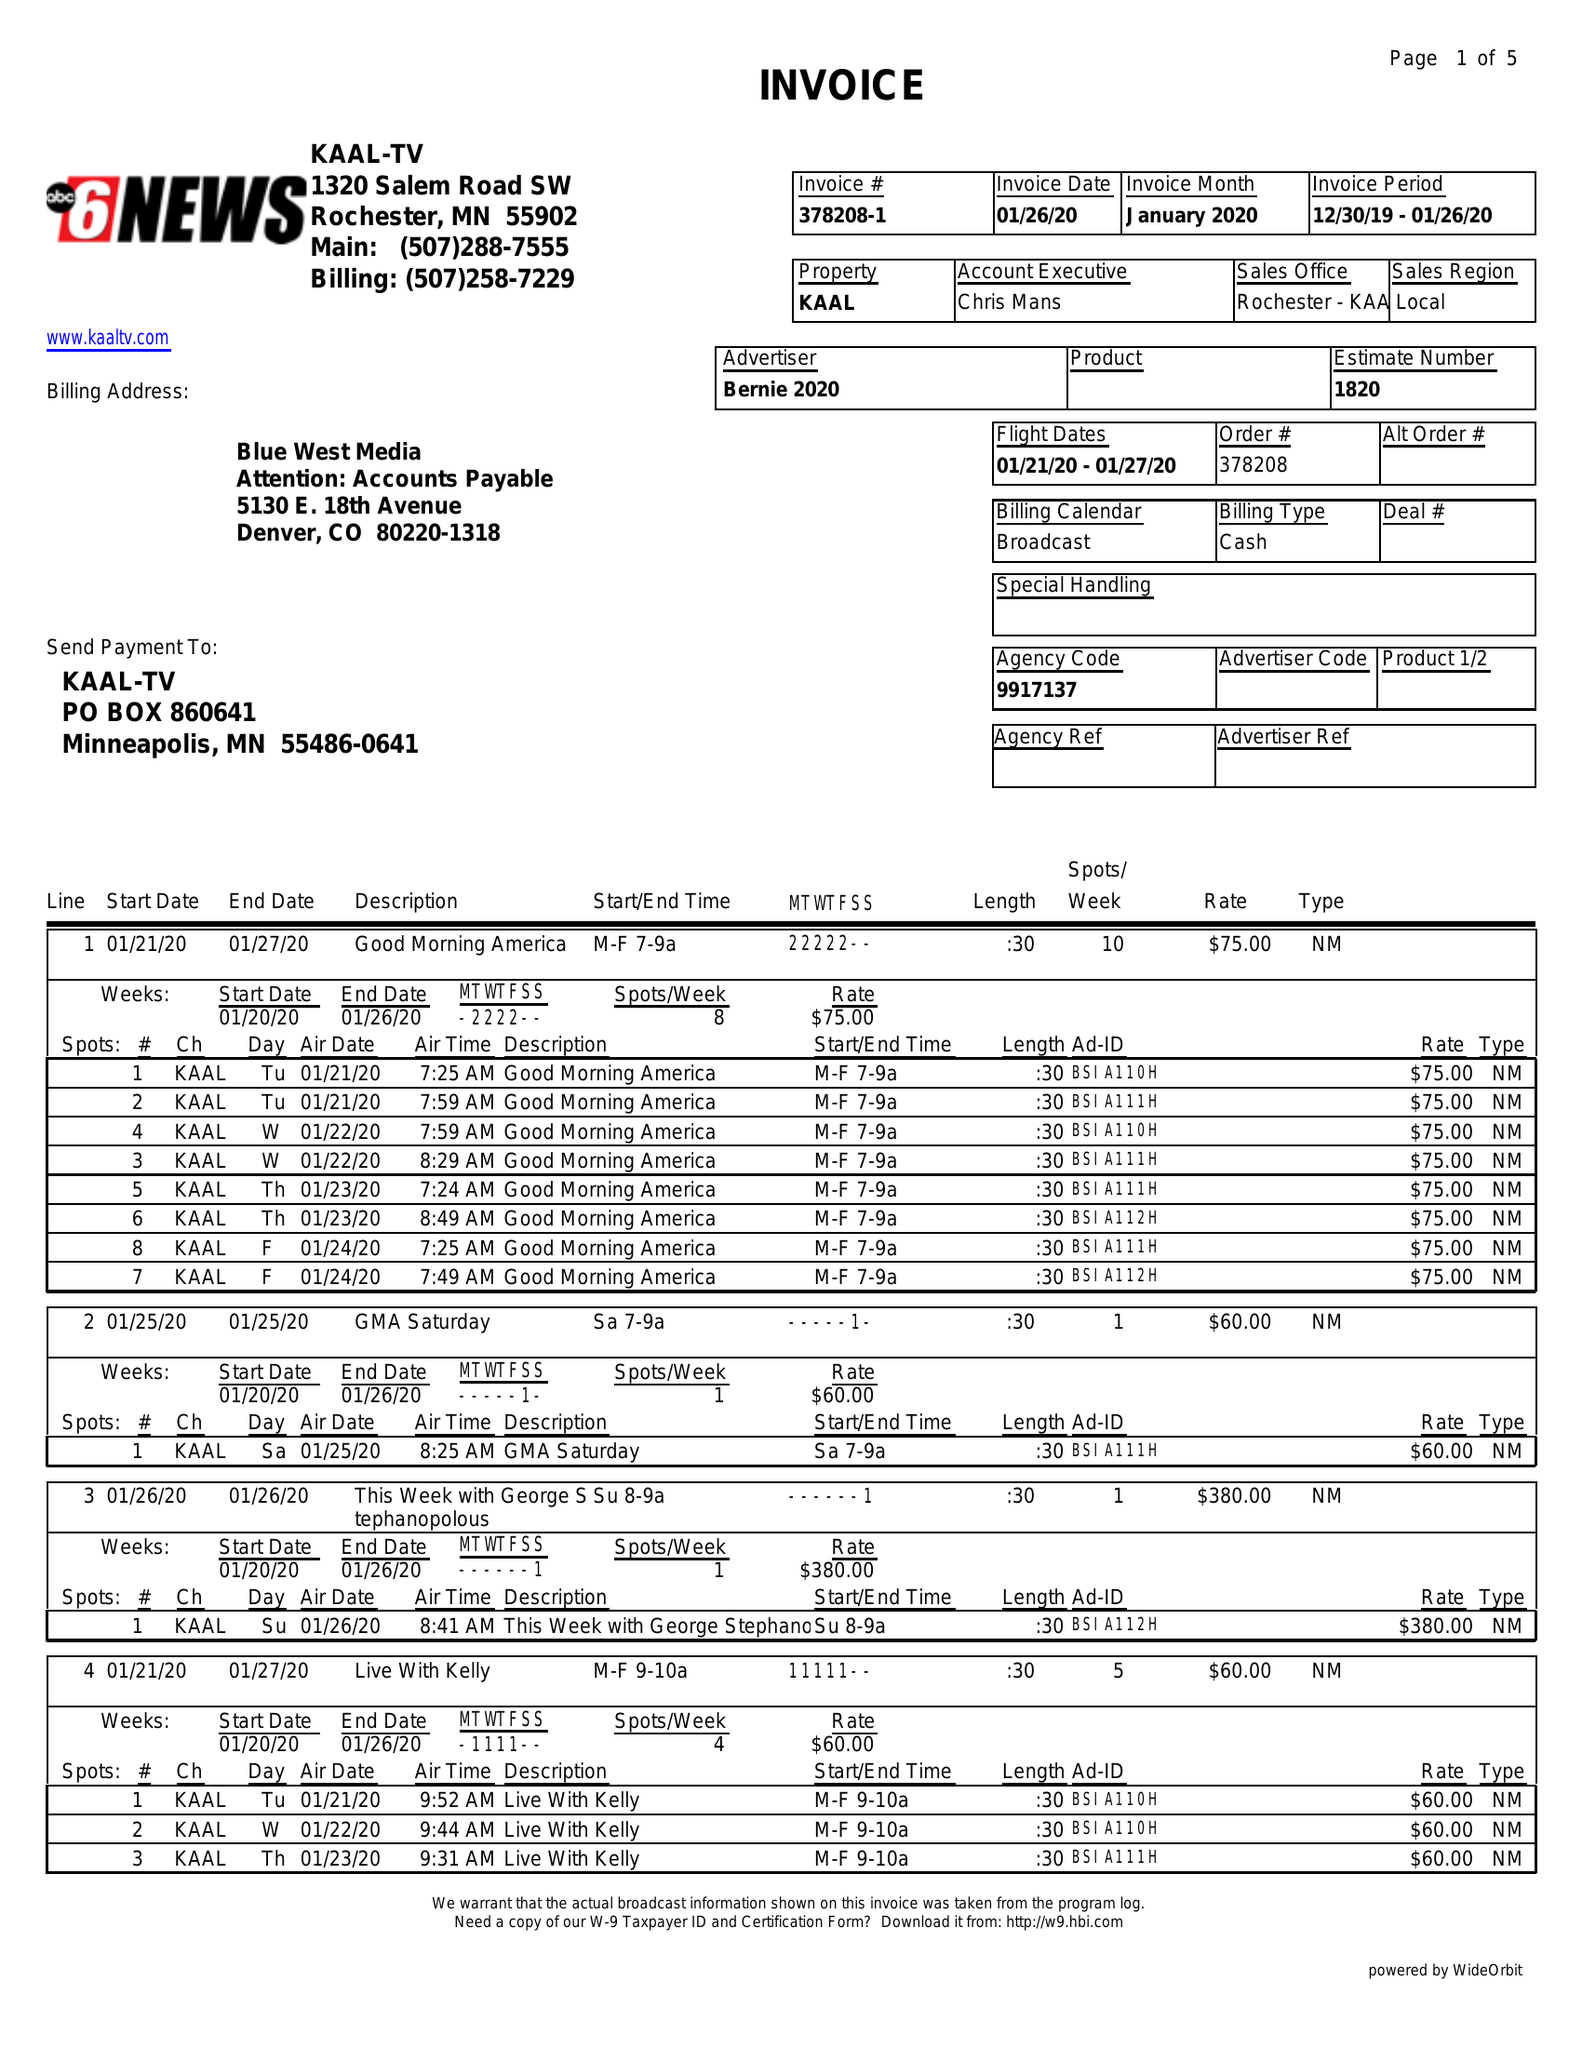What is the value for the gross_amount?
Answer the question using a single word or phrase. 12705.00 